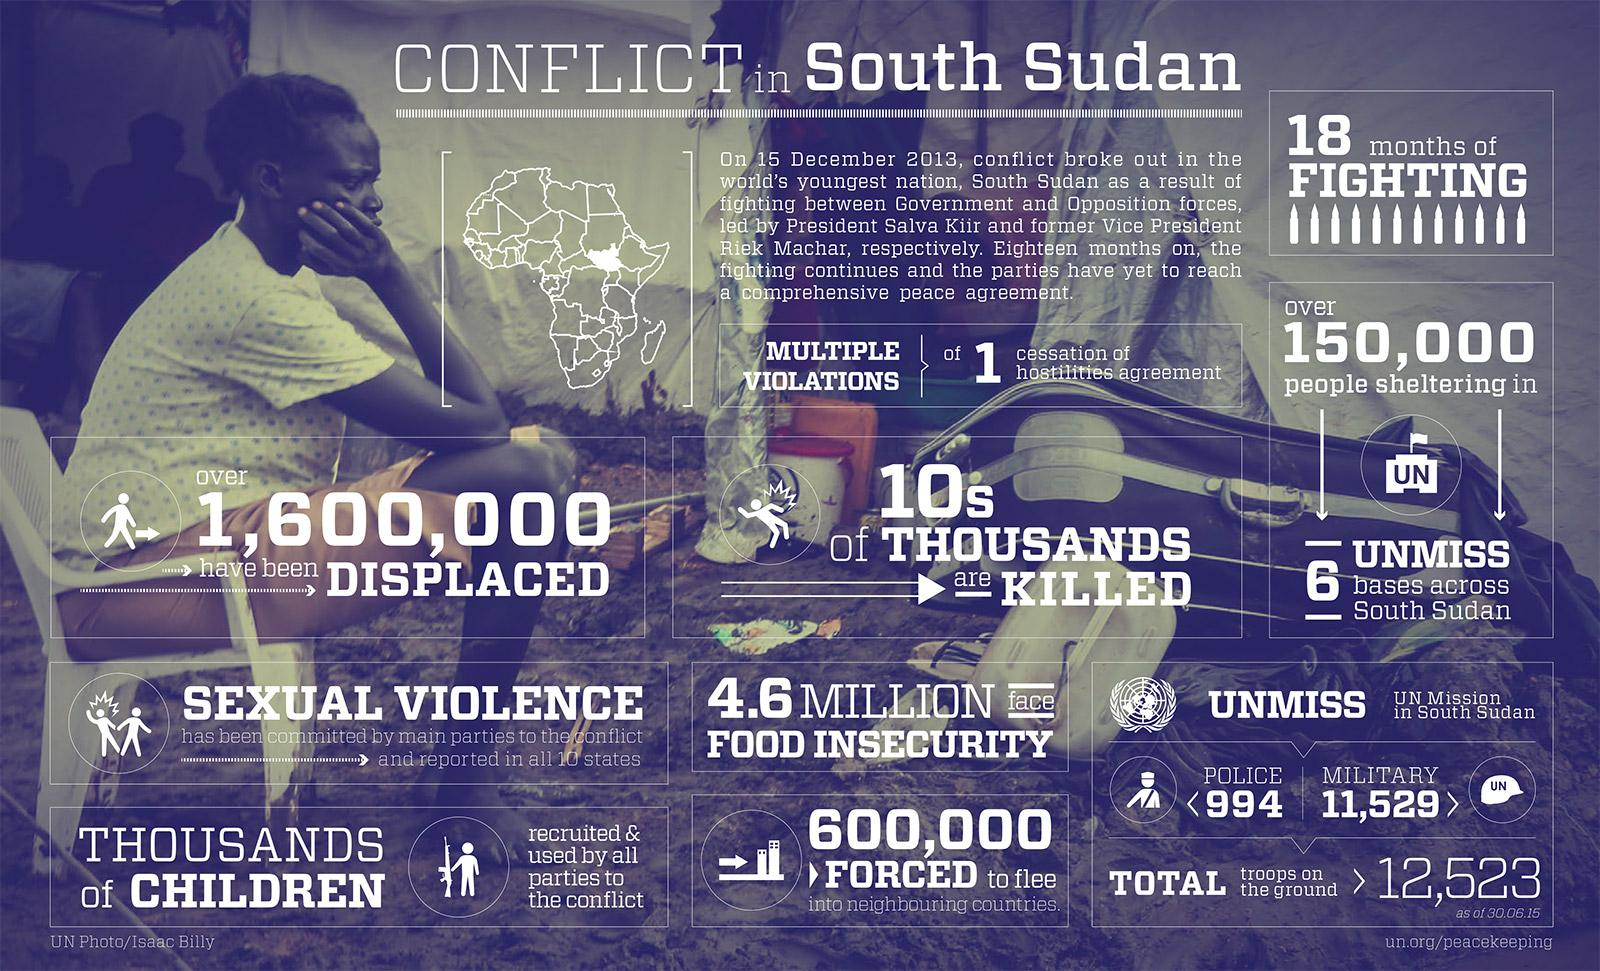Identify some key points in this picture. The conflict in South Sudan continued for 18 months until it reached a peace agreement. An estimated 600,000 people in South Sudan were forced to flee their homes due to conflict that erupted in December 2013. In South Sudan, 4.6 million people are facing food insecurity due to the conflict that erupted in December 2013. The United Nations Mission in South Sudan (UNMISS) is operated in South Sudan. As of February 2023, a total of 11,529 military personnel were deployed as part of the United Nations Mission in South Sudan (UNMISS) mission. 